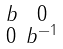<formula> <loc_0><loc_0><loc_500><loc_500>\begin{smallmatrix} b & 0 \\ 0 & b ^ { - 1 } \end{smallmatrix}</formula> 